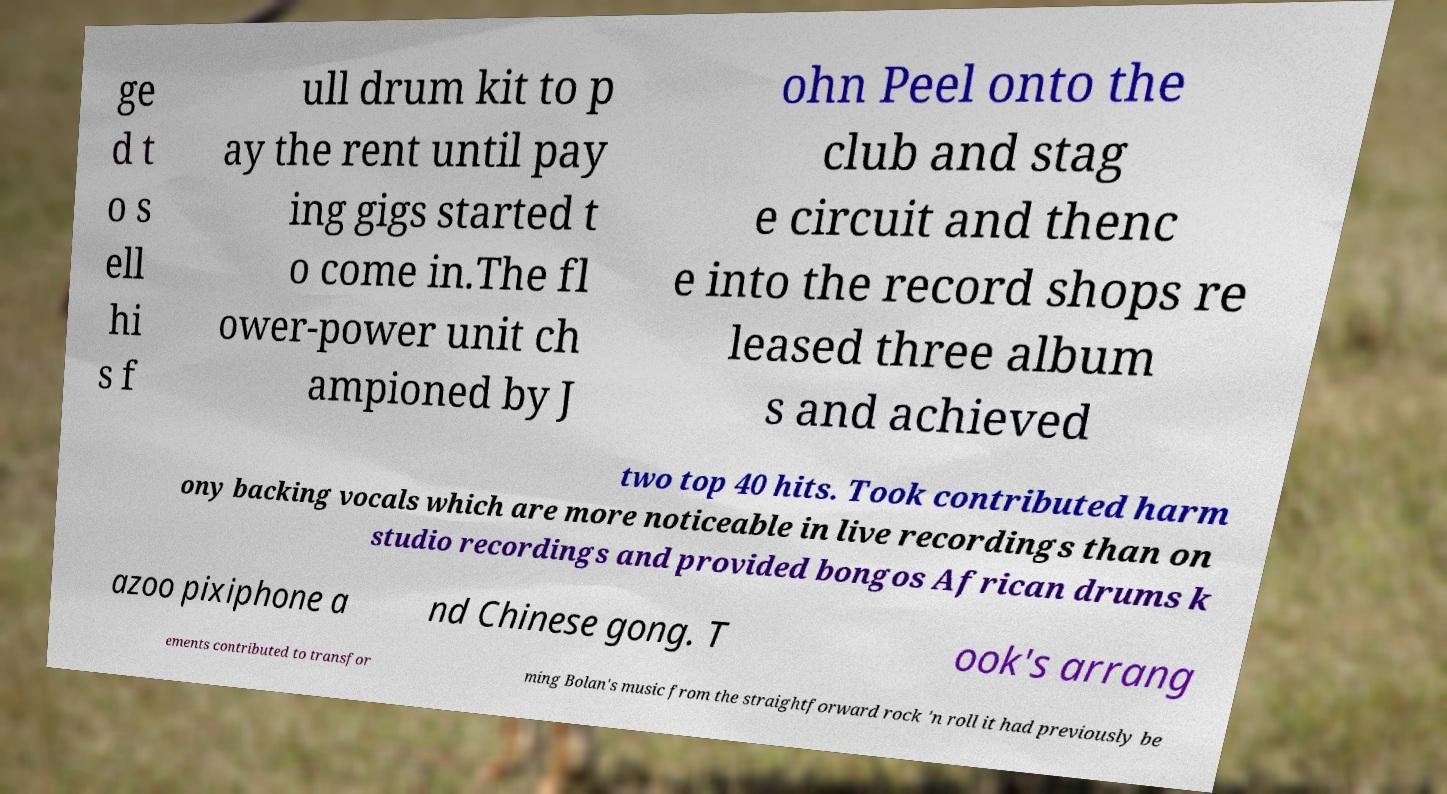Could you assist in decoding the text presented in this image and type it out clearly? ge d t o s ell hi s f ull drum kit to p ay the rent until pay ing gigs started t o come in.The fl ower-power unit ch ampioned by J ohn Peel onto the club and stag e circuit and thenc e into the record shops re leased three album s and achieved two top 40 hits. Took contributed harm ony backing vocals which are more noticeable in live recordings than on studio recordings and provided bongos African drums k azoo pixiphone a nd Chinese gong. T ook's arrang ements contributed to transfor ming Bolan's music from the straightforward rock 'n roll it had previously be 